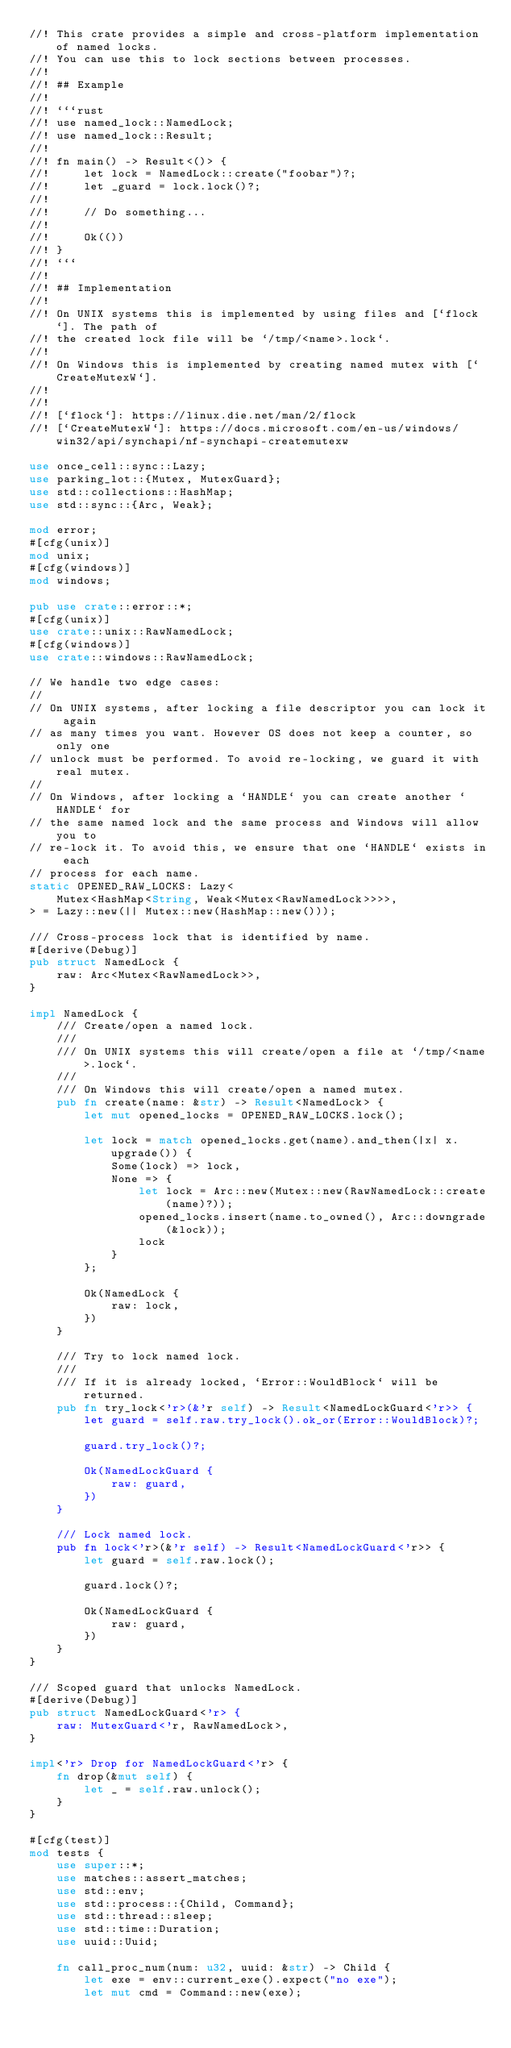Convert code to text. <code><loc_0><loc_0><loc_500><loc_500><_Rust_>//! This crate provides a simple and cross-platform implementation of named locks.
//! You can use this to lock sections between processes.
//!
//! ## Example
//!
//! ```rust
//! use named_lock::NamedLock;
//! use named_lock::Result;
//!
//! fn main() -> Result<()> {
//!     let lock = NamedLock::create("foobar")?;
//!     let _guard = lock.lock()?;
//!
//!     // Do something...
//!
//!     Ok(())
//! }
//! ```
//!
//! ## Implementation
//!
//! On UNIX systems this is implemented by using files and [`flock`]. The path of
//! the created lock file will be `/tmp/<name>.lock`.
//!
//! On Windows this is implemented by creating named mutex with [`CreateMutexW`].
//!
//!
//! [`flock`]: https://linux.die.net/man/2/flock
//! [`CreateMutexW`]: https://docs.microsoft.com/en-us/windows/win32/api/synchapi/nf-synchapi-createmutexw

use once_cell::sync::Lazy;
use parking_lot::{Mutex, MutexGuard};
use std::collections::HashMap;
use std::sync::{Arc, Weak};

mod error;
#[cfg(unix)]
mod unix;
#[cfg(windows)]
mod windows;

pub use crate::error::*;
#[cfg(unix)]
use crate::unix::RawNamedLock;
#[cfg(windows)]
use crate::windows::RawNamedLock;

// We handle two edge cases:
//
// On UNIX systems, after locking a file descriptor you can lock it again
// as many times you want. However OS does not keep a counter, so only one
// unlock must be performed. To avoid re-locking, we guard it with real mutex.
//
// On Windows, after locking a `HANDLE` you can create another `HANDLE` for
// the same named lock and the same process and Windows will allow you to
// re-lock it. To avoid this, we ensure that one `HANDLE` exists in each
// process for each name.
static OPENED_RAW_LOCKS: Lazy<
    Mutex<HashMap<String, Weak<Mutex<RawNamedLock>>>>,
> = Lazy::new(|| Mutex::new(HashMap::new()));

/// Cross-process lock that is identified by name.
#[derive(Debug)]
pub struct NamedLock {
    raw: Arc<Mutex<RawNamedLock>>,
}

impl NamedLock {
    /// Create/open a named lock.
    ///
    /// On UNIX systems this will create/open a file at `/tmp/<name>.lock`.
    ///
    /// On Windows this will create/open a named mutex.
    pub fn create(name: &str) -> Result<NamedLock> {
        let mut opened_locks = OPENED_RAW_LOCKS.lock();

        let lock = match opened_locks.get(name).and_then(|x| x.upgrade()) {
            Some(lock) => lock,
            None => {
                let lock = Arc::new(Mutex::new(RawNamedLock::create(name)?));
                opened_locks.insert(name.to_owned(), Arc::downgrade(&lock));
                lock
            }
        };

        Ok(NamedLock {
            raw: lock,
        })
    }

    /// Try to lock named lock.
    ///
    /// If it is already locked, `Error::WouldBlock` will be returned.
    pub fn try_lock<'r>(&'r self) -> Result<NamedLockGuard<'r>> {
        let guard = self.raw.try_lock().ok_or(Error::WouldBlock)?;

        guard.try_lock()?;

        Ok(NamedLockGuard {
            raw: guard,
        })
    }

    /// Lock named lock.
    pub fn lock<'r>(&'r self) -> Result<NamedLockGuard<'r>> {
        let guard = self.raw.lock();

        guard.lock()?;

        Ok(NamedLockGuard {
            raw: guard,
        })
    }
}

/// Scoped guard that unlocks NamedLock.
#[derive(Debug)]
pub struct NamedLockGuard<'r> {
    raw: MutexGuard<'r, RawNamedLock>,
}

impl<'r> Drop for NamedLockGuard<'r> {
    fn drop(&mut self) {
        let _ = self.raw.unlock();
    }
}

#[cfg(test)]
mod tests {
    use super::*;
    use matches::assert_matches;
    use std::env;
    use std::process::{Child, Command};
    use std::thread::sleep;
    use std::time::Duration;
    use uuid::Uuid;

    fn call_proc_num(num: u32, uuid: &str) -> Child {
        let exe = env::current_exe().expect("no exe");
        let mut cmd = Command::new(exe);
</code> 